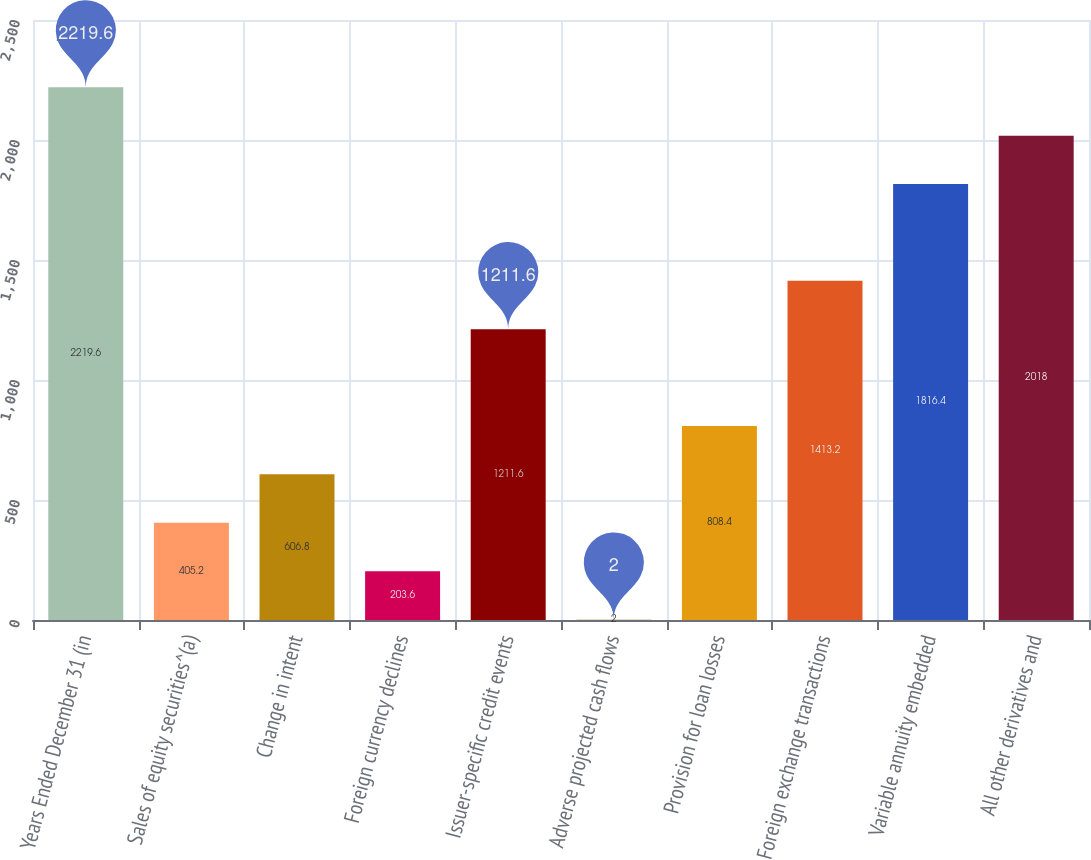Convert chart. <chart><loc_0><loc_0><loc_500><loc_500><bar_chart><fcel>Years Ended December 31 (in<fcel>Sales of equity securities^(a)<fcel>Change in intent<fcel>Foreign currency declines<fcel>Issuer-specific credit events<fcel>Adverse projected cash flows<fcel>Provision for loan losses<fcel>Foreign exchange transactions<fcel>Variable annuity embedded<fcel>All other derivatives and<nl><fcel>2219.6<fcel>405.2<fcel>606.8<fcel>203.6<fcel>1211.6<fcel>2<fcel>808.4<fcel>1413.2<fcel>1816.4<fcel>2018<nl></chart> 